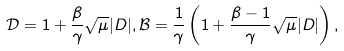Convert formula to latex. <formula><loc_0><loc_0><loc_500><loc_500>\mathcal { D } = 1 + \frac { \beta } { \gamma } \sqrt { \mu } | D | , \mathcal { B } = \frac { 1 } { \gamma } \left ( 1 + \frac { \beta - 1 } { \gamma } \sqrt { \mu } | D | \right ) ,</formula> 